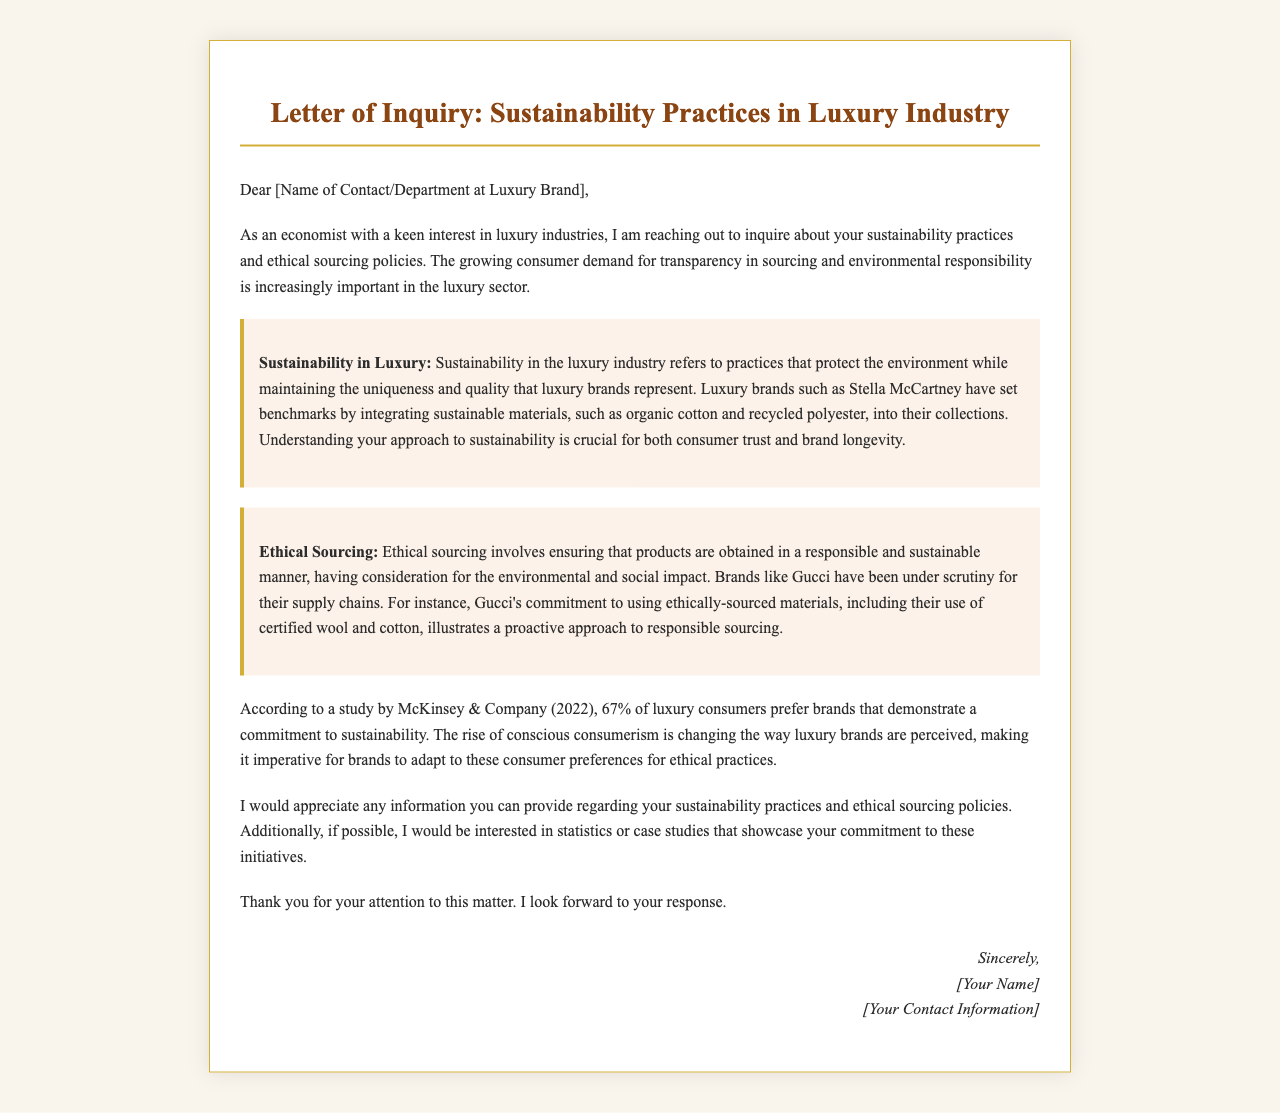What is the name of the organization mentioned in the study? The study referenced is by McKinsey & Company, which is noted in the context of consumer preferences for sustainability in luxury brands.
Answer: McKinsey & Company What percentage of luxury consumers prefer sustainable brands? The document states that 67% of luxury consumers prefer brands that demonstrate a commitment to sustainability.
Answer: 67% Which luxury brand is mentioned as a benchmark for integrating sustainable materials? Stella McCartney is highlighted as a brand that has set benchmarks in sustainable practices.
Answer: Stella McCartney What type of cotton is mentioned as part of Gucci’s ethical sourcing? The document mentions certified wool and cotton being used by Gucci in their commitment to responsible sourcing.
Answer: certified wool and cotton What is a key aspect of sustainability in the luxury industry? The highlighted section defines sustainability in this industry as practices that protect the environment while maintaining uniqueness and quality.
Answer: protect the environment What is the main focus of the letter? The letter is primarily focused on inquiring about the recipient's sustainability practices and ethical sourcing policies.
Answer: sustainability practices and ethical sourcing policies 